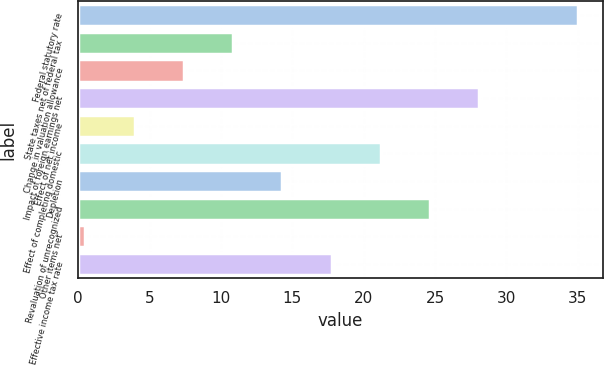Convert chart to OTSL. <chart><loc_0><loc_0><loc_500><loc_500><bar_chart><fcel>Federal statutory rate<fcel>State taxes net of federal tax<fcel>Change in valuation allowance<fcel>Impact of foreign earnings net<fcel>Effect of net income<fcel>Effect of completing domestic<fcel>Depletion<fcel>Revaluation of unrecognized<fcel>Other items net<fcel>Effective income tax rate<nl><fcel>35<fcel>10.85<fcel>7.4<fcel>28.1<fcel>3.95<fcel>21.2<fcel>14.3<fcel>24.65<fcel>0.5<fcel>17.75<nl></chart> 